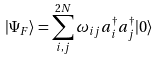<formula> <loc_0><loc_0><loc_500><loc_500>| \Psi _ { F } \rangle = \sum _ { i , j } ^ { 2 N } \omega _ { i j } a ^ { \dag } _ { i } a ^ { \dag } _ { j } | 0 \rangle</formula> 